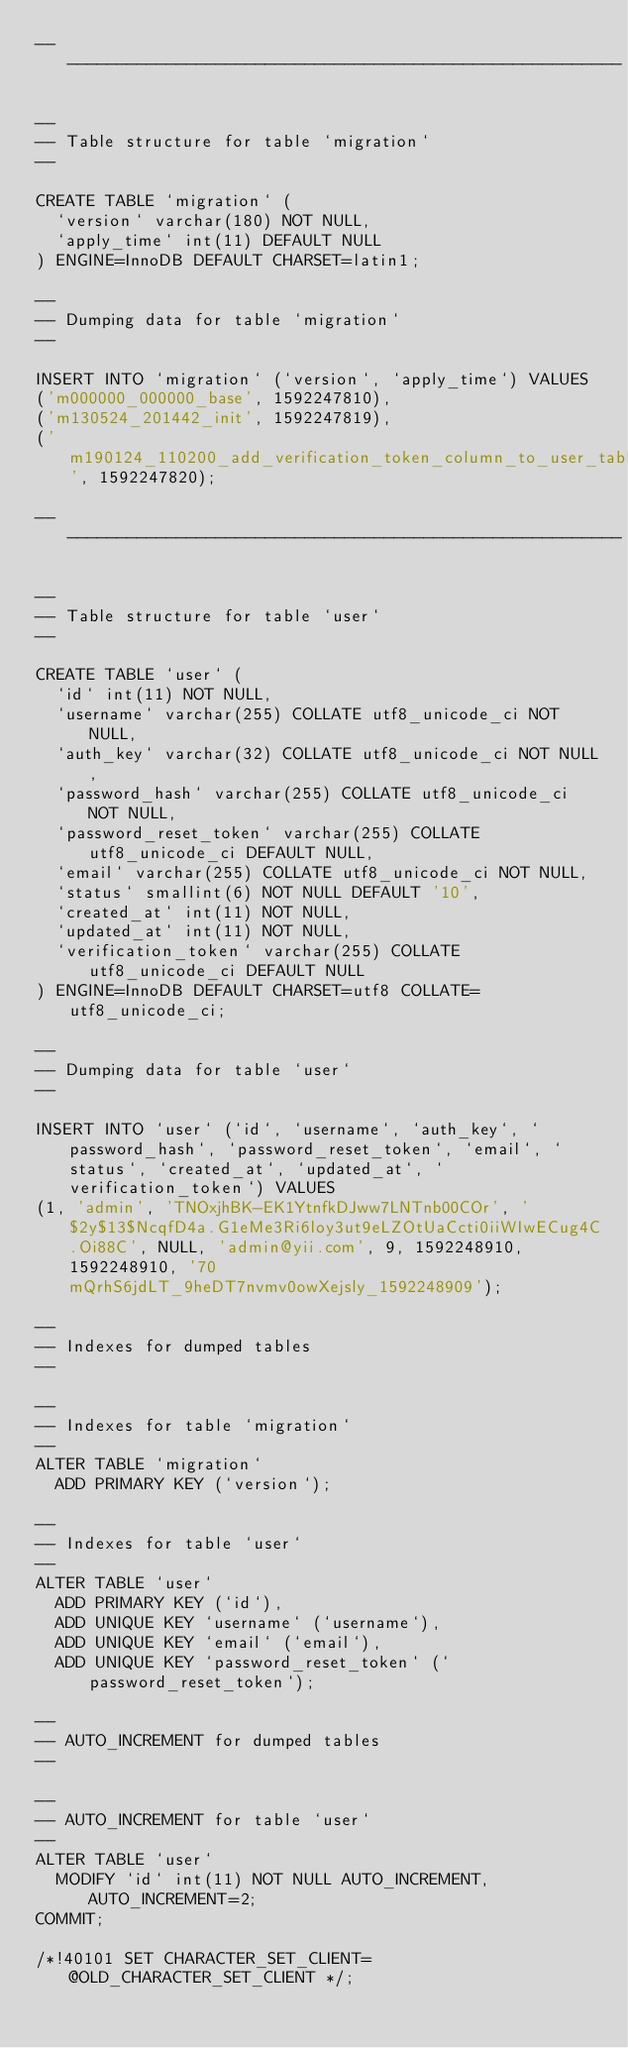Convert code to text. <code><loc_0><loc_0><loc_500><loc_500><_SQL_>-- --------------------------------------------------------

--
-- Table structure for table `migration`
--

CREATE TABLE `migration` (
  `version` varchar(180) NOT NULL,
  `apply_time` int(11) DEFAULT NULL
) ENGINE=InnoDB DEFAULT CHARSET=latin1;

--
-- Dumping data for table `migration`
--

INSERT INTO `migration` (`version`, `apply_time`) VALUES
('m000000_000000_base', 1592247810),
('m130524_201442_init', 1592247819),
('m190124_110200_add_verification_token_column_to_user_table', 1592247820);

-- --------------------------------------------------------

--
-- Table structure for table `user`
--

CREATE TABLE `user` (
  `id` int(11) NOT NULL,
  `username` varchar(255) COLLATE utf8_unicode_ci NOT NULL,
  `auth_key` varchar(32) COLLATE utf8_unicode_ci NOT NULL,
  `password_hash` varchar(255) COLLATE utf8_unicode_ci NOT NULL,
  `password_reset_token` varchar(255) COLLATE utf8_unicode_ci DEFAULT NULL,
  `email` varchar(255) COLLATE utf8_unicode_ci NOT NULL,
  `status` smallint(6) NOT NULL DEFAULT '10',
  `created_at` int(11) NOT NULL,
  `updated_at` int(11) NOT NULL,
  `verification_token` varchar(255) COLLATE utf8_unicode_ci DEFAULT NULL
) ENGINE=InnoDB DEFAULT CHARSET=utf8 COLLATE=utf8_unicode_ci;

--
-- Dumping data for table `user`
--

INSERT INTO `user` (`id`, `username`, `auth_key`, `password_hash`, `password_reset_token`, `email`, `status`, `created_at`, `updated_at`, `verification_token`) VALUES
(1, 'admin', 'TNOxjhBK-EK1YtnfkDJww7LNTnb00COr', '$2y$13$NcqfD4a.G1eMe3Ri6loy3ut9eLZOtUaCcti0iiWIwECug4C.Oi88C', NULL, 'admin@yii.com', 9, 1592248910, 1592248910, '70mQrhS6jdLT_9heDT7nvmv0owXejsly_1592248909');

--
-- Indexes for dumped tables
--

--
-- Indexes for table `migration`
--
ALTER TABLE `migration`
  ADD PRIMARY KEY (`version`);

--
-- Indexes for table `user`
--
ALTER TABLE `user`
  ADD PRIMARY KEY (`id`),
  ADD UNIQUE KEY `username` (`username`),
  ADD UNIQUE KEY `email` (`email`),
  ADD UNIQUE KEY `password_reset_token` (`password_reset_token`);

--
-- AUTO_INCREMENT for dumped tables
--

--
-- AUTO_INCREMENT for table `user`
--
ALTER TABLE `user`
  MODIFY `id` int(11) NOT NULL AUTO_INCREMENT, AUTO_INCREMENT=2;
COMMIT;

/*!40101 SET CHARACTER_SET_CLIENT=@OLD_CHARACTER_SET_CLIENT */;</code> 